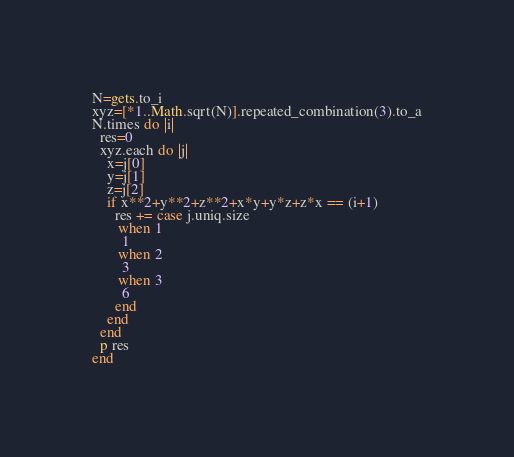<code> <loc_0><loc_0><loc_500><loc_500><_Ruby_>N=gets.to_i
xyz=[*1..Math.sqrt(N)].repeated_combination(3).to_a
N.times do |i|
  res=0
  xyz.each do |j|
    x=j[0]
    y=j[1]
    z=j[2]
    if x**2+y**2+z**2+x*y+y*z+z*x == (i+1)
      res += case j.uniq.size
       when 1
        1
       when 2
        3
       when 3
        6
      end
    end
  end
  p res
end
</code> 